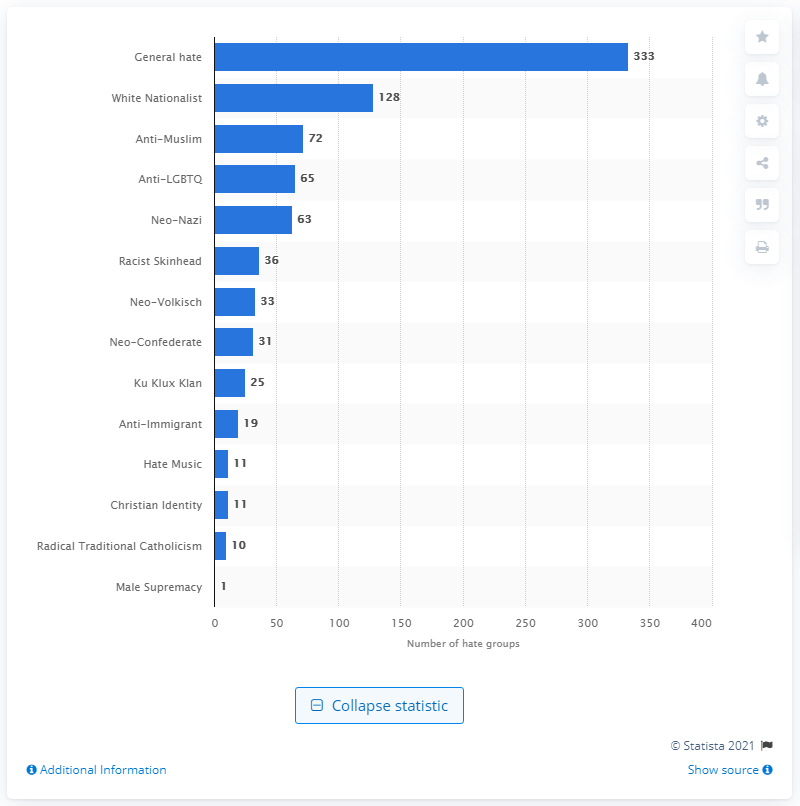Identify some key points in this picture. There were 25 Ku Klux Klan groups in the United States in 2020. 